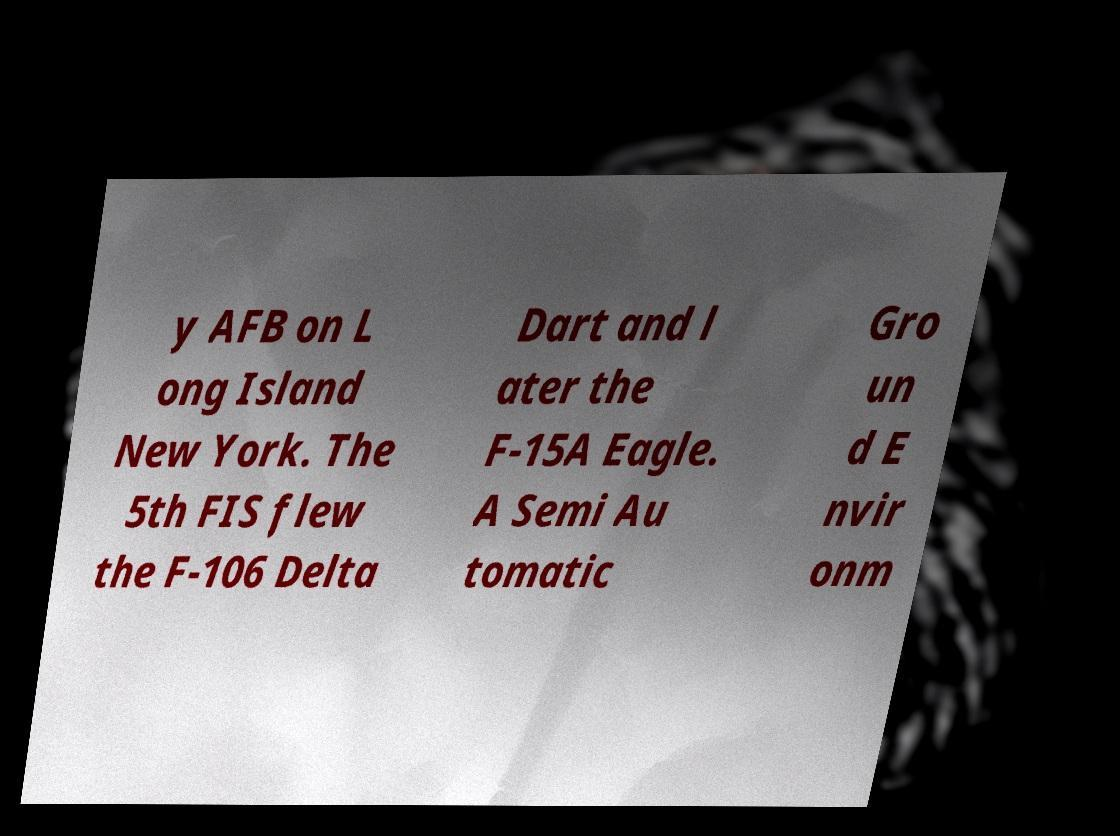Can you accurately transcribe the text from the provided image for me? y AFB on L ong Island New York. The 5th FIS flew the F-106 Delta Dart and l ater the F-15A Eagle. A Semi Au tomatic Gro un d E nvir onm 